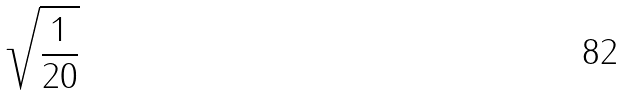Convert formula to latex. <formula><loc_0><loc_0><loc_500><loc_500>\sqrt { \frac { 1 } { 2 0 } }</formula> 